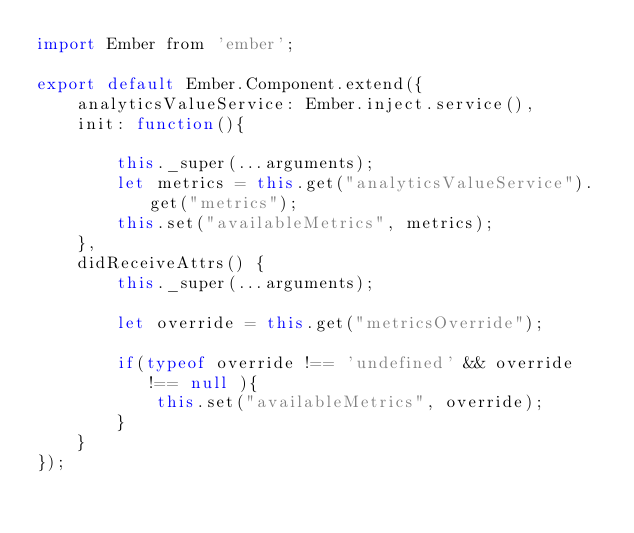<code> <loc_0><loc_0><loc_500><loc_500><_JavaScript_>import Ember from 'ember';

export default Ember.Component.extend({
    analyticsValueService: Ember.inject.service(),
    init: function(){

        this._super(...arguments);
        let metrics = this.get("analyticsValueService").get("metrics");
        this.set("availableMetrics", metrics);
    },
    didReceiveAttrs() {
        this._super(...arguments);

        let override = this.get("metricsOverride");

        if(typeof override !== 'undefined' && override !== null ){
            this.set("availableMetrics", override);
        }
    }
});
</code> 